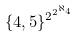Convert formula to latex. <formula><loc_0><loc_0><loc_500><loc_500>\{ 4 , 5 \} ^ { 2 ^ { 2 ^ { \aleph _ { 4 } } } }</formula> 